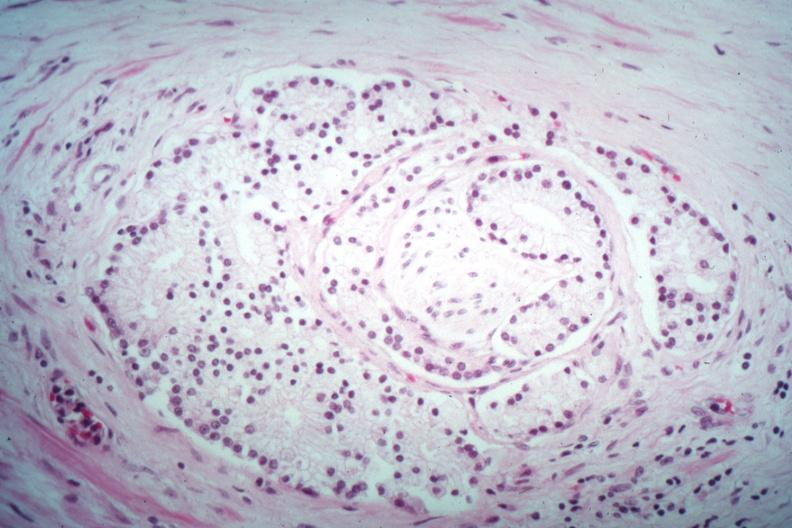what is present?
Answer the question using a single word or phrase. Prostate 